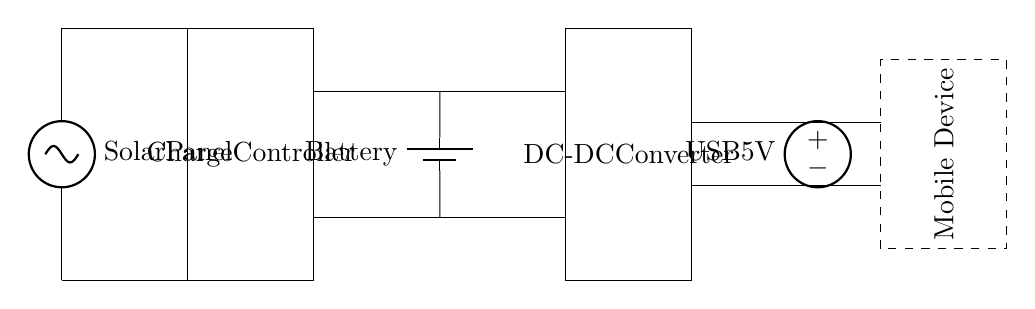What is the main power source in this circuit? The main power source is the solar panel, which converts sunlight into electrical energy to charge the battery.
Answer: solar panel What component is used to regulate the voltage from the solar panel? The component used to regulate the voltage is the charge controller, which ensures the battery is charged efficiently and safely.
Answer: charge controller How many components are involved in this charging circuit? The charging circuit involves five components: a solar panel, charge controller, battery, DC-DC converter, and USB output.
Answer: five What is the output voltage provided to the mobile device? The output voltage provided to the mobile device is 5 volts, supplied by the USB output in the circuit for device charging.
Answer: 5 volts Why is a DC-DC converter needed in this circuit? A DC-DC converter is needed to adjust the output voltage from the battery to a level suitable for charging the mobile device, ensuring compatibility and efficiency.
Answer: to adjust output voltage What does the rectangular box labeled "Mobile Device" represent? The rectangular box represents the mobile device being charged, which connects to the circuit's output for receiving power.
Answer: mobile device What role does the battery play in this circuit? The battery stores energy generated by the solar panel and releases it through the circuit, ensuring a steady power supply even when sunlight is not available.
Answer: stores energy 